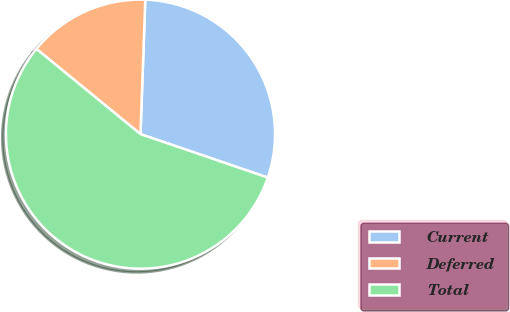Convert chart to OTSL. <chart><loc_0><loc_0><loc_500><loc_500><pie_chart><fcel>Current<fcel>Deferred<fcel>Total<nl><fcel>29.67%<fcel>14.65%<fcel>55.69%<nl></chart> 